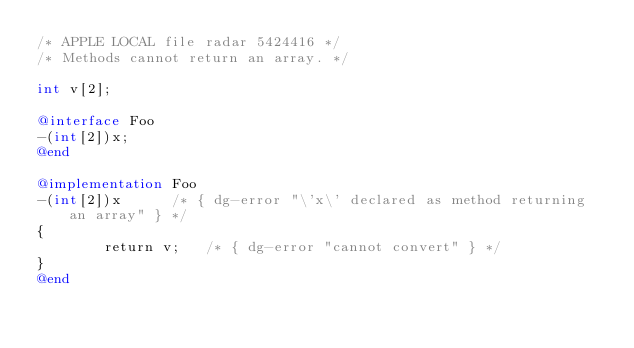Convert code to text. <code><loc_0><loc_0><loc_500><loc_500><_ObjectiveC_>/* APPLE LOCAL file radar 5424416 */
/* Methods cannot return an array. */

int v[2];

@interface Foo
-(int[2])x;
@end

@implementation Foo
-(int[2])x		/* { dg-error "\'x\' declared as method returning an array" } */
{
        return v;	/* { dg-error "cannot convert" } */
}
@end

</code> 